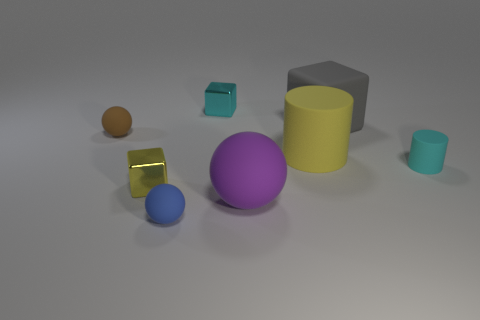What material appears to be used for the objects, and can you describe the surface they are resting on? The objects in the image seem to have a matte finish, suggestive of a plastic or possibly painted wood material. They rest on a flat, lightly textured surface that could be interpreted as a simple matte ground or table. Do the shadows give any indication of the light source? Yes, the shadows are soft and diffuse, indicating the light source is not particularly close to the objects and is diffused, such as from an overhead softbox or window on an overcast day. 